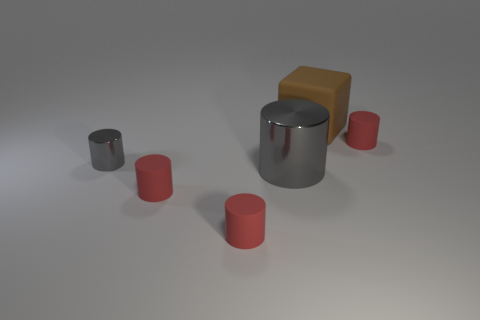Is the color of the large matte cube the same as the tiny metallic cylinder?
Offer a very short reply. No. What number of brown things are large shiny spheres or small shiny cylinders?
Offer a very short reply. 0. There is a block; are there any big brown things on the right side of it?
Your response must be concise. No. How big is the matte block?
Your response must be concise. Large. There is another shiny object that is the same shape as the small gray shiny object; what is its size?
Keep it short and to the point. Large. What number of metal cylinders are in front of the small red matte thing that is right of the big brown rubber cube?
Your response must be concise. 2. Does the red cylinder that is to the right of the brown rubber cube have the same material as the gray cylinder on the left side of the large shiny thing?
Your answer should be compact. No. What number of other large matte objects have the same shape as the big brown object?
Your answer should be compact. 0. What number of rubber objects have the same color as the rubber block?
Provide a succinct answer. 0. Does the tiny red object that is behind the tiny gray shiny cylinder have the same shape as the large thing that is in front of the brown matte thing?
Provide a short and direct response. Yes. 